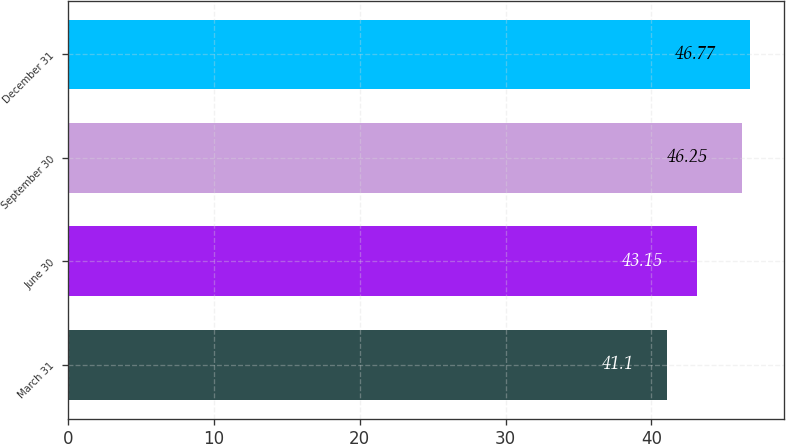Convert chart to OTSL. <chart><loc_0><loc_0><loc_500><loc_500><bar_chart><fcel>March 31<fcel>June 30<fcel>September 30<fcel>December 31<nl><fcel>41.1<fcel>43.15<fcel>46.25<fcel>46.77<nl></chart> 